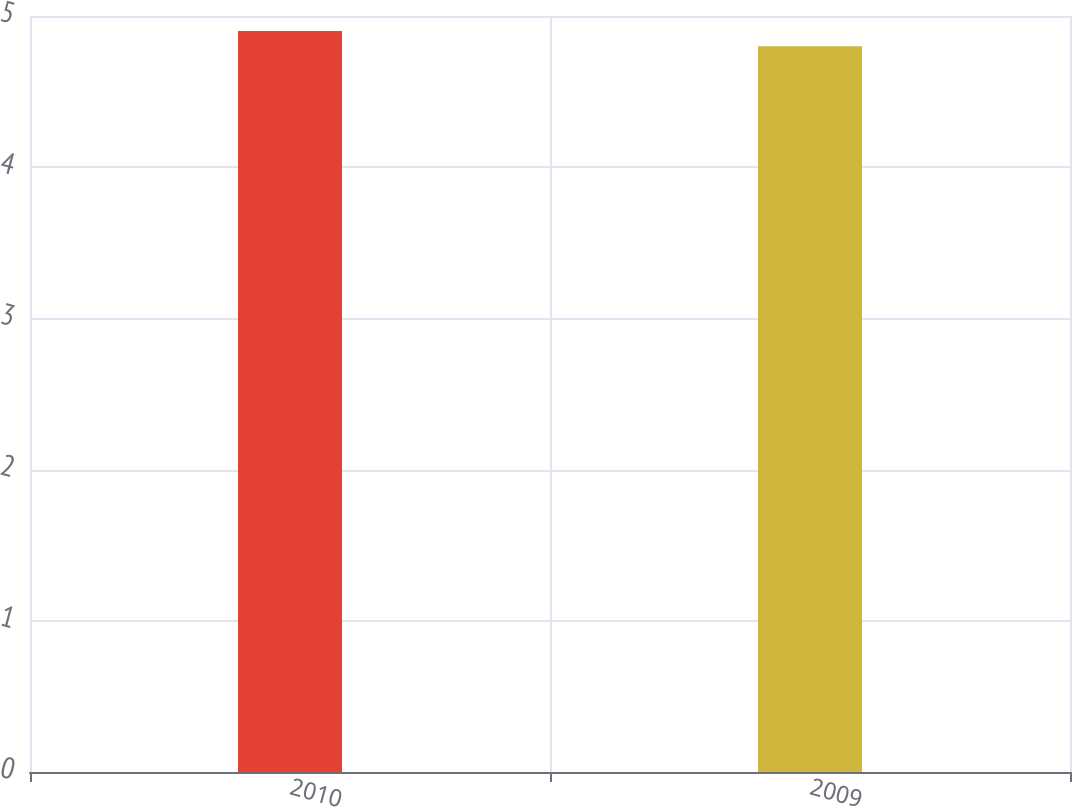Convert chart. <chart><loc_0><loc_0><loc_500><loc_500><bar_chart><fcel>2010<fcel>2009<nl><fcel>4.9<fcel>4.8<nl></chart> 